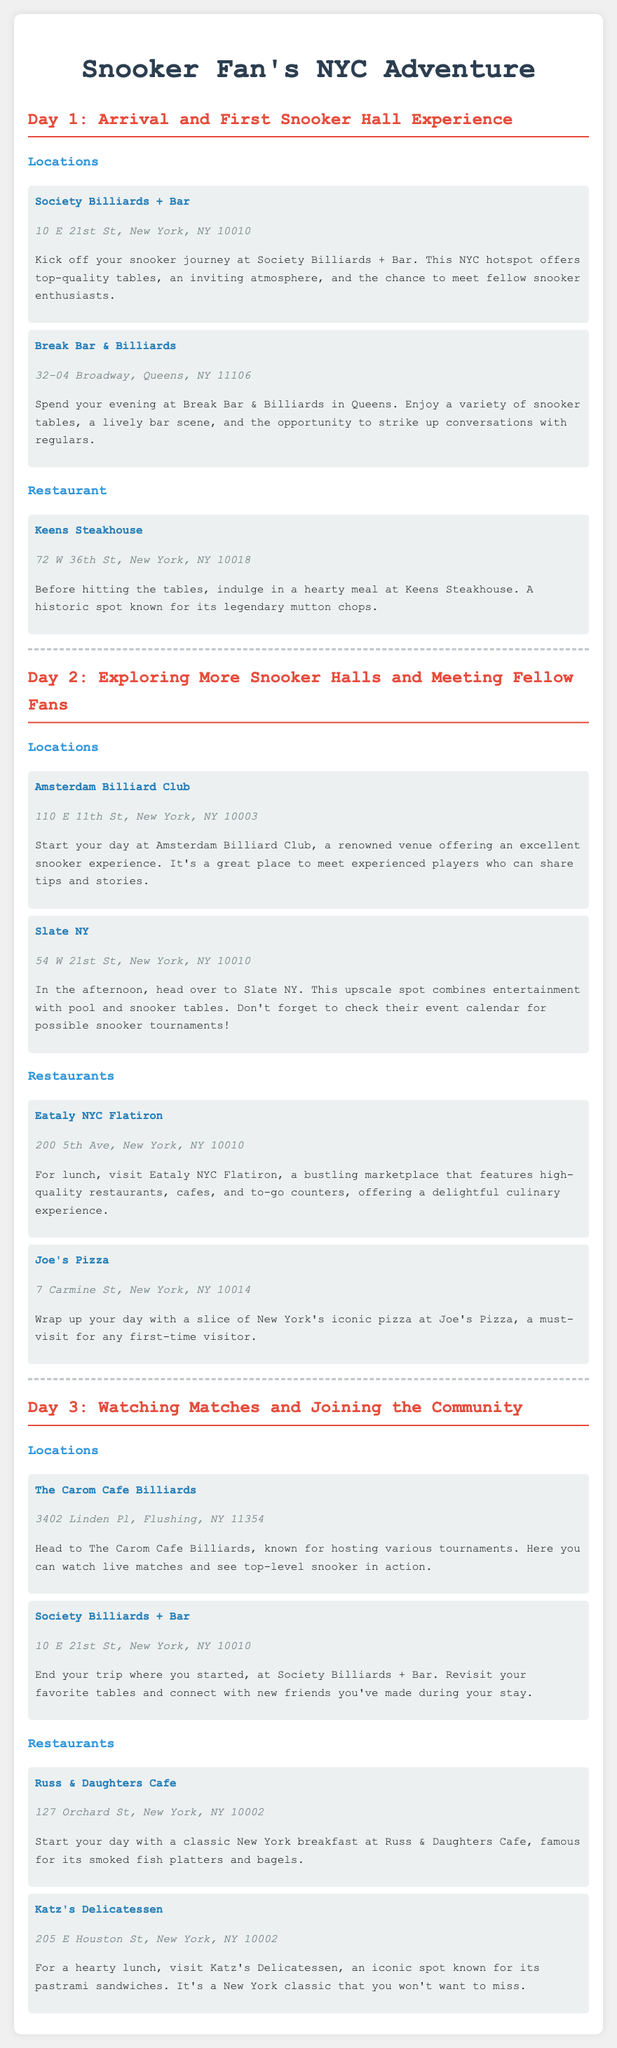What is the address of Society Billiards + Bar? The address is provided in the document under the location details for Society Billiards + Bar.
Answer: 10 E 21st St, New York, NY 10010 What restaurant is known for its mutton chops? The description of Keens Steakhouse mentions its famous mutton chops.
Answer: Keens Steakhouse How many locations are mentioned for Day 2? The document indicates two specific locations visited on Day 2, both under the "Locations" section.
Answer: 2 Which venue is highlighted for watching live matches? The Carom Cafe Billiards is mentioned as a place to watch live matches.
Answer: The Carom Cafe Billiards What is the name of the deli famous for pastrami sandwiches? Katz's Delicatessen is noted for its renowned pastrami sandwiches in the document.
Answer: Katz's Delicatessen Which snooker hall is visited on both Day 1 and Day 3? The document indicates that Society Billiards + Bar is listed on both days.
Answer: Society Billiards + Bar What type of cuisine does Eataly NYC Flatiron offer? The document describes Eataly NYC Flatiron as a marketplace featuring high-quality restaurants and cafes.
Answer: Italian What activity can you do at Slate NY? The document mentions that you can check their event calendar for possible snooker tournaments.
Answer: Tournaments What is the primary theme of the itinerary? The document outlines activities centered around snooker halls and related experiences.
Answer: Snooker 